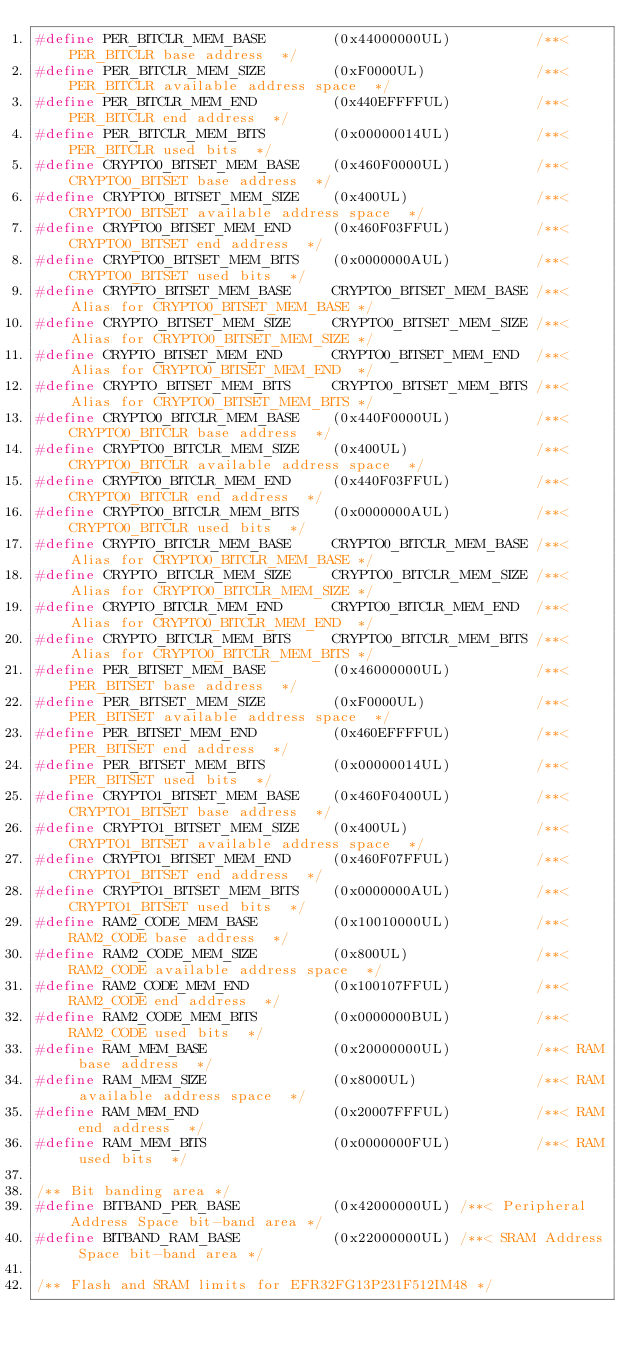<code> <loc_0><loc_0><loc_500><loc_500><_C_>#define PER_BITCLR_MEM_BASE        (0x44000000UL)          /**< PER_BITCLR base address  */
#define PER_BITCLR_MEM_SIZE        (0xF0000UL)             /**< PER_BITCLR available address space  */
#define PER_BITCLR_MEM_END         (0x440EFFFFUL)          /**< PER_BITCLR end address  */
#define PER_BITCLR_MEM_BITS        (0x00000014UL)          /**< PER_BITCLR used bits  */
#define CRYPTO0_BITSET_MEM_BASE    (0x460F0000UL)          /**< CRYPTO0_BITSET base address  */
#define CRYPTO0_BITSET_MEM_SIZE    (0x400UL)               /**< CRYPTO0_BITSET available address space  */
#define CRYPTO0_BITSET_MEM_END     (0x460F03FFUL)          /**< CRYPTO0_BITSET end address  */
#define CRYPTO0_BITSET_MEM_BITS    (0x0000000AUL)          /**< CRYPTO0_BITSET used bits  */
#define CRYPTO_BITSET_MEM_BASE     CRYPTO0_BITSET_MEM_BASE /**< Alias for CRYPTO0_BITSET_MEM_BASE */
#define CRYPTO_BITSET_MEM_SIZE     CRYPTO0_BITSET_MEM_SIZE /**< Alias for CRYPTO0_BITSET_MEM_SIZE */
#define CRYPTO_BITSET_MEM_END      CRYPTO0_BITSET_MEM_END  /**< Alias for CRYPTO0_BITSET_MEM_END  */
#define CRYPTO_BITSET_MEM_BITS     CRYPTO0_BITSET_MEM_BITS /**< Alias for CRYPTO0_BITSET_MEM_BITS */
#define CRYPTO0_BITCLR_MEM_BASE    (0x440F0000UL)          /**< CRYPTO0_BITCLR base address  */
#define CRYPTO0_BITCLR_MEM_SIZE    (0x400UL)               /**< CRYPTO0_BITCLR available address space  */
#define CRYPTO0_BITCLR_MEM_END     (0x440F03FFUL)          /**< CRYPTO0_BITCLR end address  */
#define CRYPTO0_BITCLR_MEM_BITS    (0x0000000AUL)          /**< CRYPTO0_BITCLR used bits  */
#define CRYPTO_BITCLR_MEM_BASE     CRYPTO0_BITCLR_MEM_BASE /**< Alias for CRYPTO0_BITCLR_MEM_BASE */
#define CRYPTO_BITCLR_MEM_SIZE     CRYPTO0_BITCLR_MEM_SIZE /**< Alias for CRYPTO0_BITCLR_MEM_SIZE */
#define CRYPTO_BITCLR_MEM_END      CRYPTO0_BITCLR_MEM_END  /**< Alias for CRYPTO0_BITCLR_MEM_END  */
#define CRYPTO_BITCLR_MEM_BITS     CRYPTO0_BITCLR_MEM_BITS /**< Alias for CRYPTO0_BITCLR_MEM_BITS */
#define PER_BITSET_MEM_BASE        (0x46000000UL)          /**< PER_BITSET base address  */
#define PER_BITSET_MEM_SIZE        (0xF0000UL)             /**< PER_BITSET available address space  */
#define PER_BITSET_MEM_END         (0x460EFFFFUL)          /**< PER_BITSET end address  */
#define PER_BITSET_MEM_BITS        (0x00000014UL)          /**< PER_BITSET used bits  */
#define CRYPTO1_BITSET_MEM_BASE    (0x460F0400UL)          /**< CRYPTO1_BITSET base address  */
#define CRYPTO1_BITSET_MEM_SIZE    (0x400UL)               /**< CRYPTO1_BITSET available address space  */
#define CRYPTO1_BITSET_MEM_END     (0x460F07FFUL)          /**< CRYPTO1_BITSET end address  */
#define CRYPTO1_BITSET_MEM_BITS    (0x0000000AUL)          /**< CRYPTO1_BITSET used bits  */
#define RAM2_CODE_MEM_BASE         (0x10010000UL)          /**< RAM2_CODE base address  */
#define RAM2_CODE_MEM_SIZE         (0x800UL)               /**< RAM2_CODE available address space  */
#define RAM2_CODE_MEM_END          (0x100107FFUL)          /**< RAM2_CODE end address  */
#define RAM2_CODE_MEM_BITS         (0x0000000BUL)          /**< RAM2_CODE used bits  */
#define RAM_MEM_BASE               (0x20000000UL)          /**< RAM base address  */
#define RAM_MEM_SIZE               (0x8000UL)              /**< RAM available address space  */
#define RAM_MEM_END                (0x20007FFFUL)          /**< RAM end address  */
#define RAM_MEM_BITS               (0x0000000FUL)          /**< RAM used bits  */

/** Bit banding area */
#define BITBAND_PER_BASE           (0x42000000UL) /**< Peripheral Address Space bit-band area */
#define BITBAND_RAM_BASE           (0x22000000UL) /**< SRAM Address Space bit-band area */

/** Flash and SRAM limits for EFR32FG13P231F512IM48 */</code> 